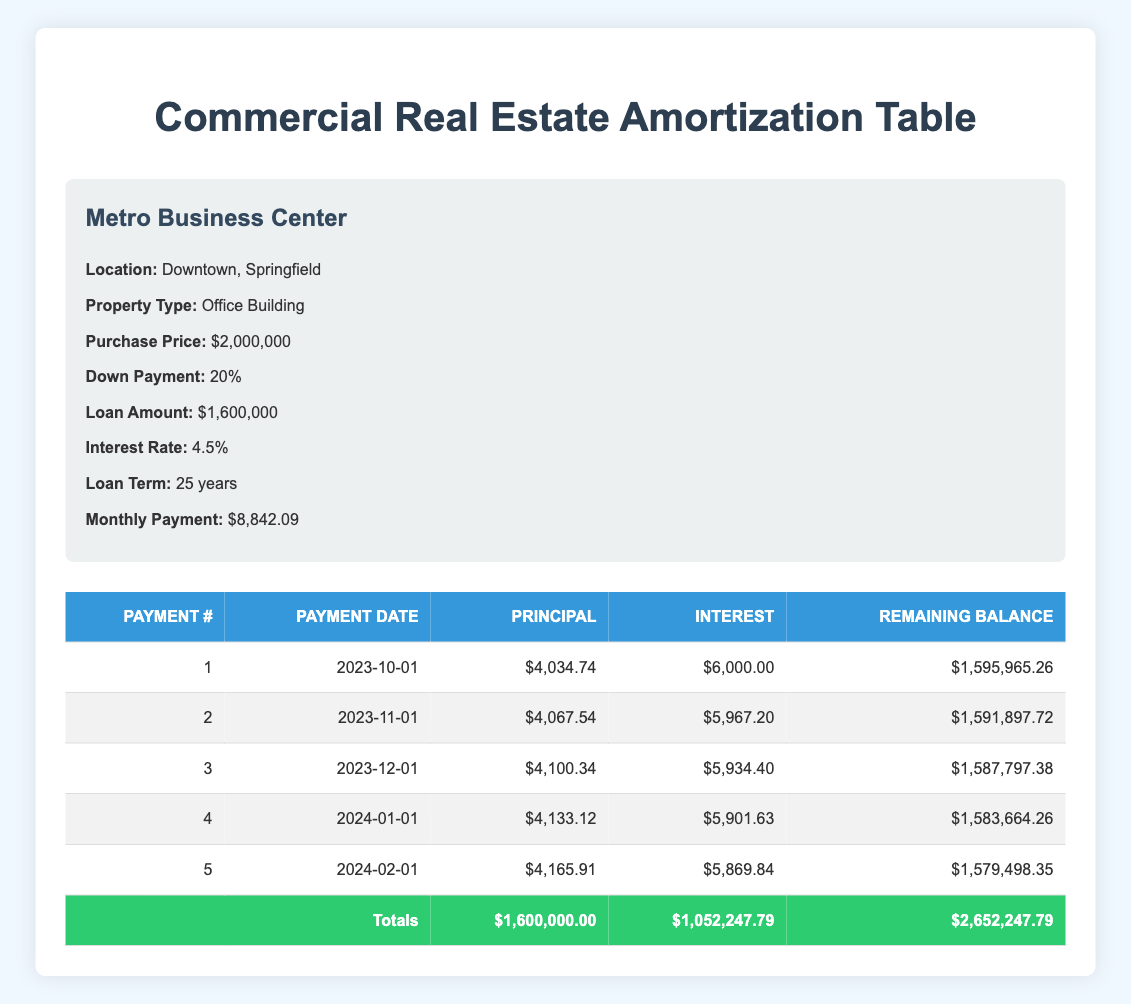What is the purchase price of the property? The purchase price of the property is listed as 2,000,000 in the property details section.
Answer: 2,000,000 How much is the monthly payment for the loan? The monthly payment for the loan is specified as 8,842.09 in the amortization details.
Answer: 8,842.09 What is the total amount of interest paid over the loan term? The total interest paid over the loan term is indicated as 1,052,247.79 in the amortization details section.
Answer: 1,052,247.79 Was the principal payment for the first payment greater than the monthly payment? The principal payment for the first payment is 4,034.74, which is less than the monthly payment of 8,842.09. Therefore, the statement is false.
Answer: No What is the remaining balance after the second payment? The remaining balance after the second payment is given as 1,591,897.72 in the table.
Answer: 1,591,897.72 How much total money is paid after the first 5 payments? The total of the payments made after the first 5 payments is calculated by summing the monthly payment of 8,842.09 multiplied by 5, resulting in a total of 44,210.45.
Answer: 44,210.45 Which payment has the lowest principal payment? The information shows that the first payment includes a principal payment of 4,034.74, which is the lowest among the first five payments.
Answer: 4,034.74 What percentage of the total payment is interest? The total payment is 2,652,247.79 and total interest is 1,052,247.79. Calculating the percentage gives (1,052,247.79 / 2,652,247.79) * 100 = approximately 39.7%.
Answer: 39.7% What is the total principal paid after the first 5 payments? To find the total principal paid, we must sum the principal payments from each of the first 5 payments: 4,034.74 + 4,067.54 + 4,100.34 + 4,133.12 + 4,165.91, which equals 20,502.65.
Answer: 20,502.65 